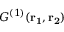Convert formula to latex. <formula><loc_0><loc_0><loc_500><loc_500>{ G ^ { ( 1 ) } } ( r _ { 1 } , r _ { 2 } )</formula> 